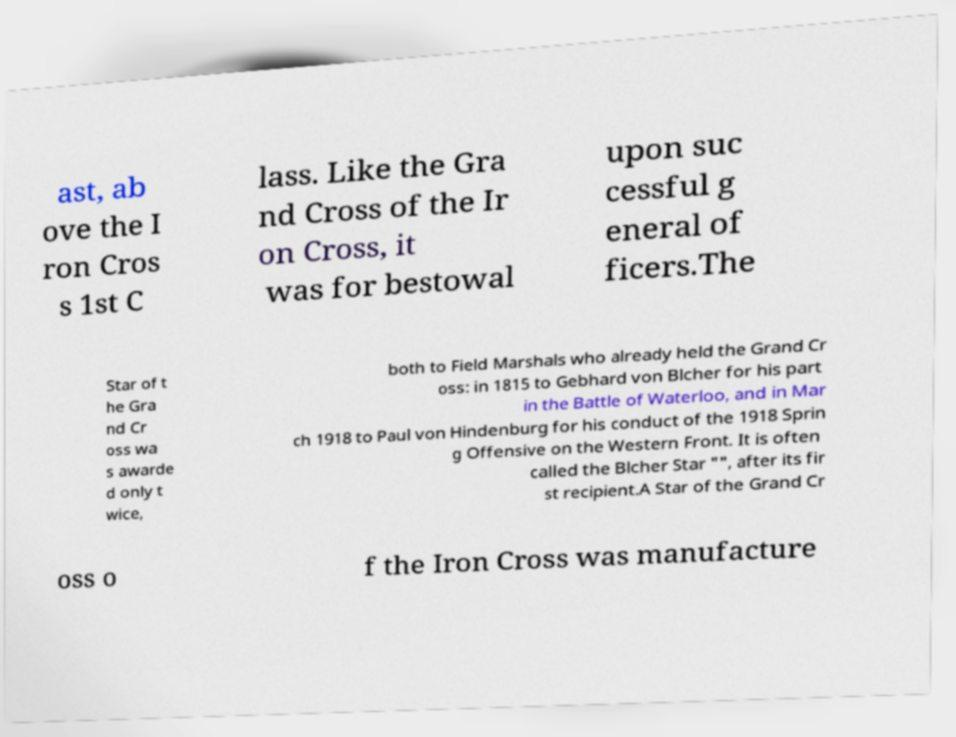Could you extract and type out the text from this image? ast, ab ove the I ron Cros s 1st C lass. Like the Gra nd Cross of the Ir on Cross, it was for bestowal upon suc cessful g eneral of ficers.The Star of t he Gra nd Cr oss wa s awarde d only t wice, both to Field Marshals who already held the Grand Cr oss: in 1815 to Gebhard von Blcher for his part in the Battle of Waterloo, and in Mar ch 1918 to Paul von Hindenburg for his conduct of the 1918 Sprin g Offensive on the Western Front. It is often called the Blcher Star "", after its fir st recipient.A Star of the Grand Cr oss o f the Iron Cross was manufacture 